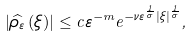Convert formula to latex. <formula><loc_0><loc_0><loc_500><loc_500>\left | \widehat { \rho _ { \varepsilon } } \left ( \xi \right ) \right | \leq c \varepsilon ^ { - m } e ^ { - \nu \varepsilon ^ { \frac { 1 } { \sigma } } \left | \xi \right | ^ { \frac { 1 } { \sigma } } } ,</formula> 